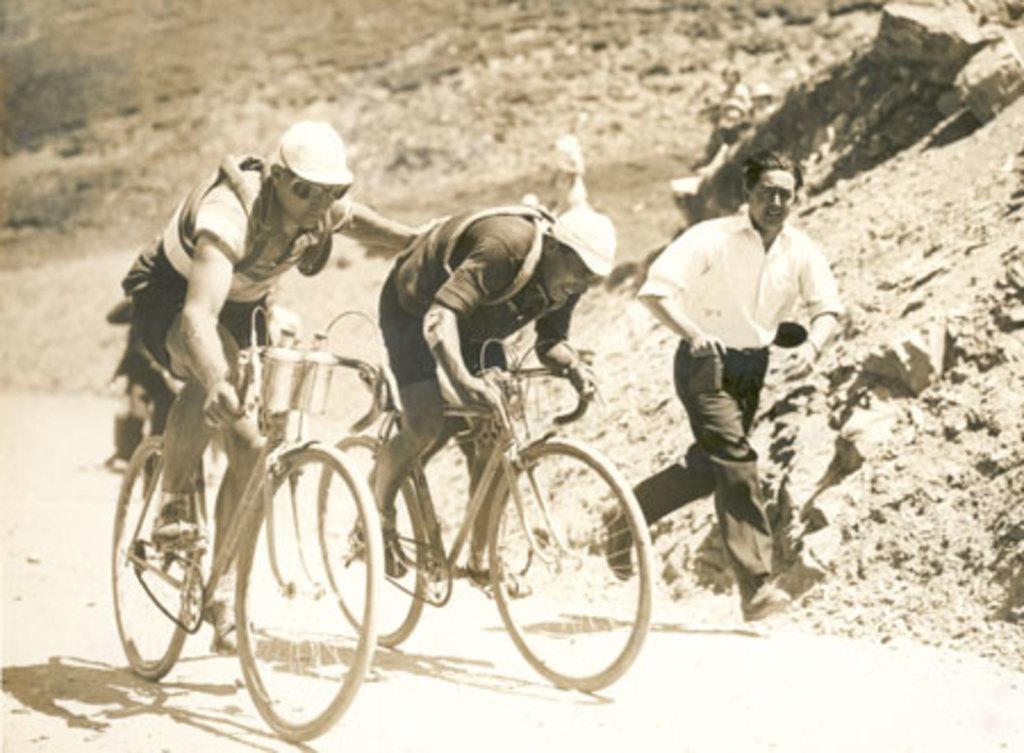How would you summarize this image in a sentence or two? In this image we can see two persons are riding their bicycles on the road. This man is running on the road. In the background we can see a rock hill. 